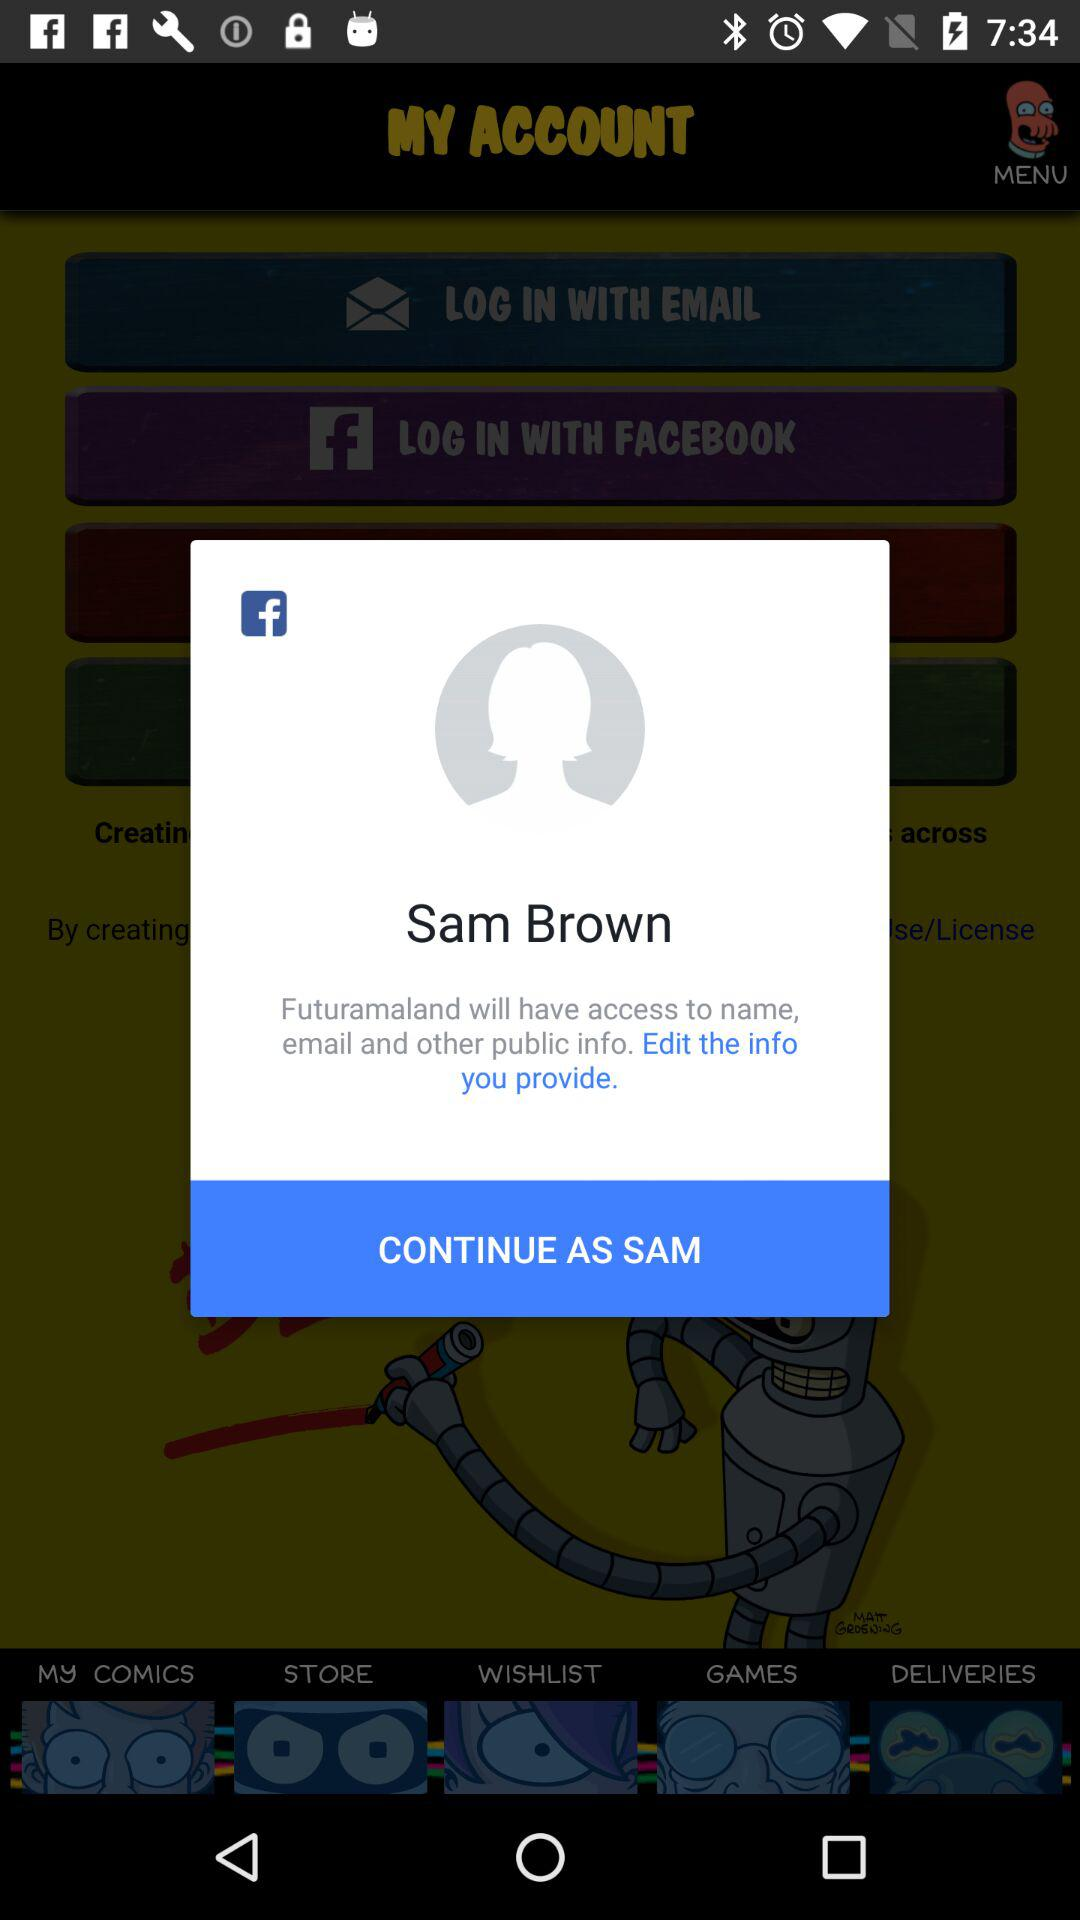What application will have access to the name, email and other public information? The application "Futuramaland" will have access to the name, email and other public information. 